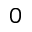Convert formula to latex. <formula><loc_0><loc_0><loc_500><loc_500>_ { 0 }</formula> 